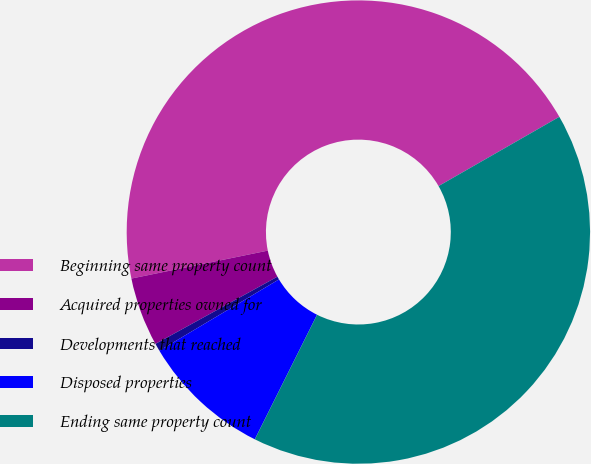Convert chart to OTSL. <chart><loc_0><loc_0><loc_500><loc_500><pie_chart><fcel>Beginning same property count<fcel>Acquired properties owned for<fcel>Developments that reached<fcel>Disposed properties<fcel>Ending same property count<nl><fcel>44.93%<fcel>4.8%<fcel>0.54%<fcel>9.07%<fcel>40.66%<nl></chart> 